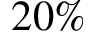<formula> <loc_0><loc_0><loc_500><loc_500>2 0 \%</formula> 